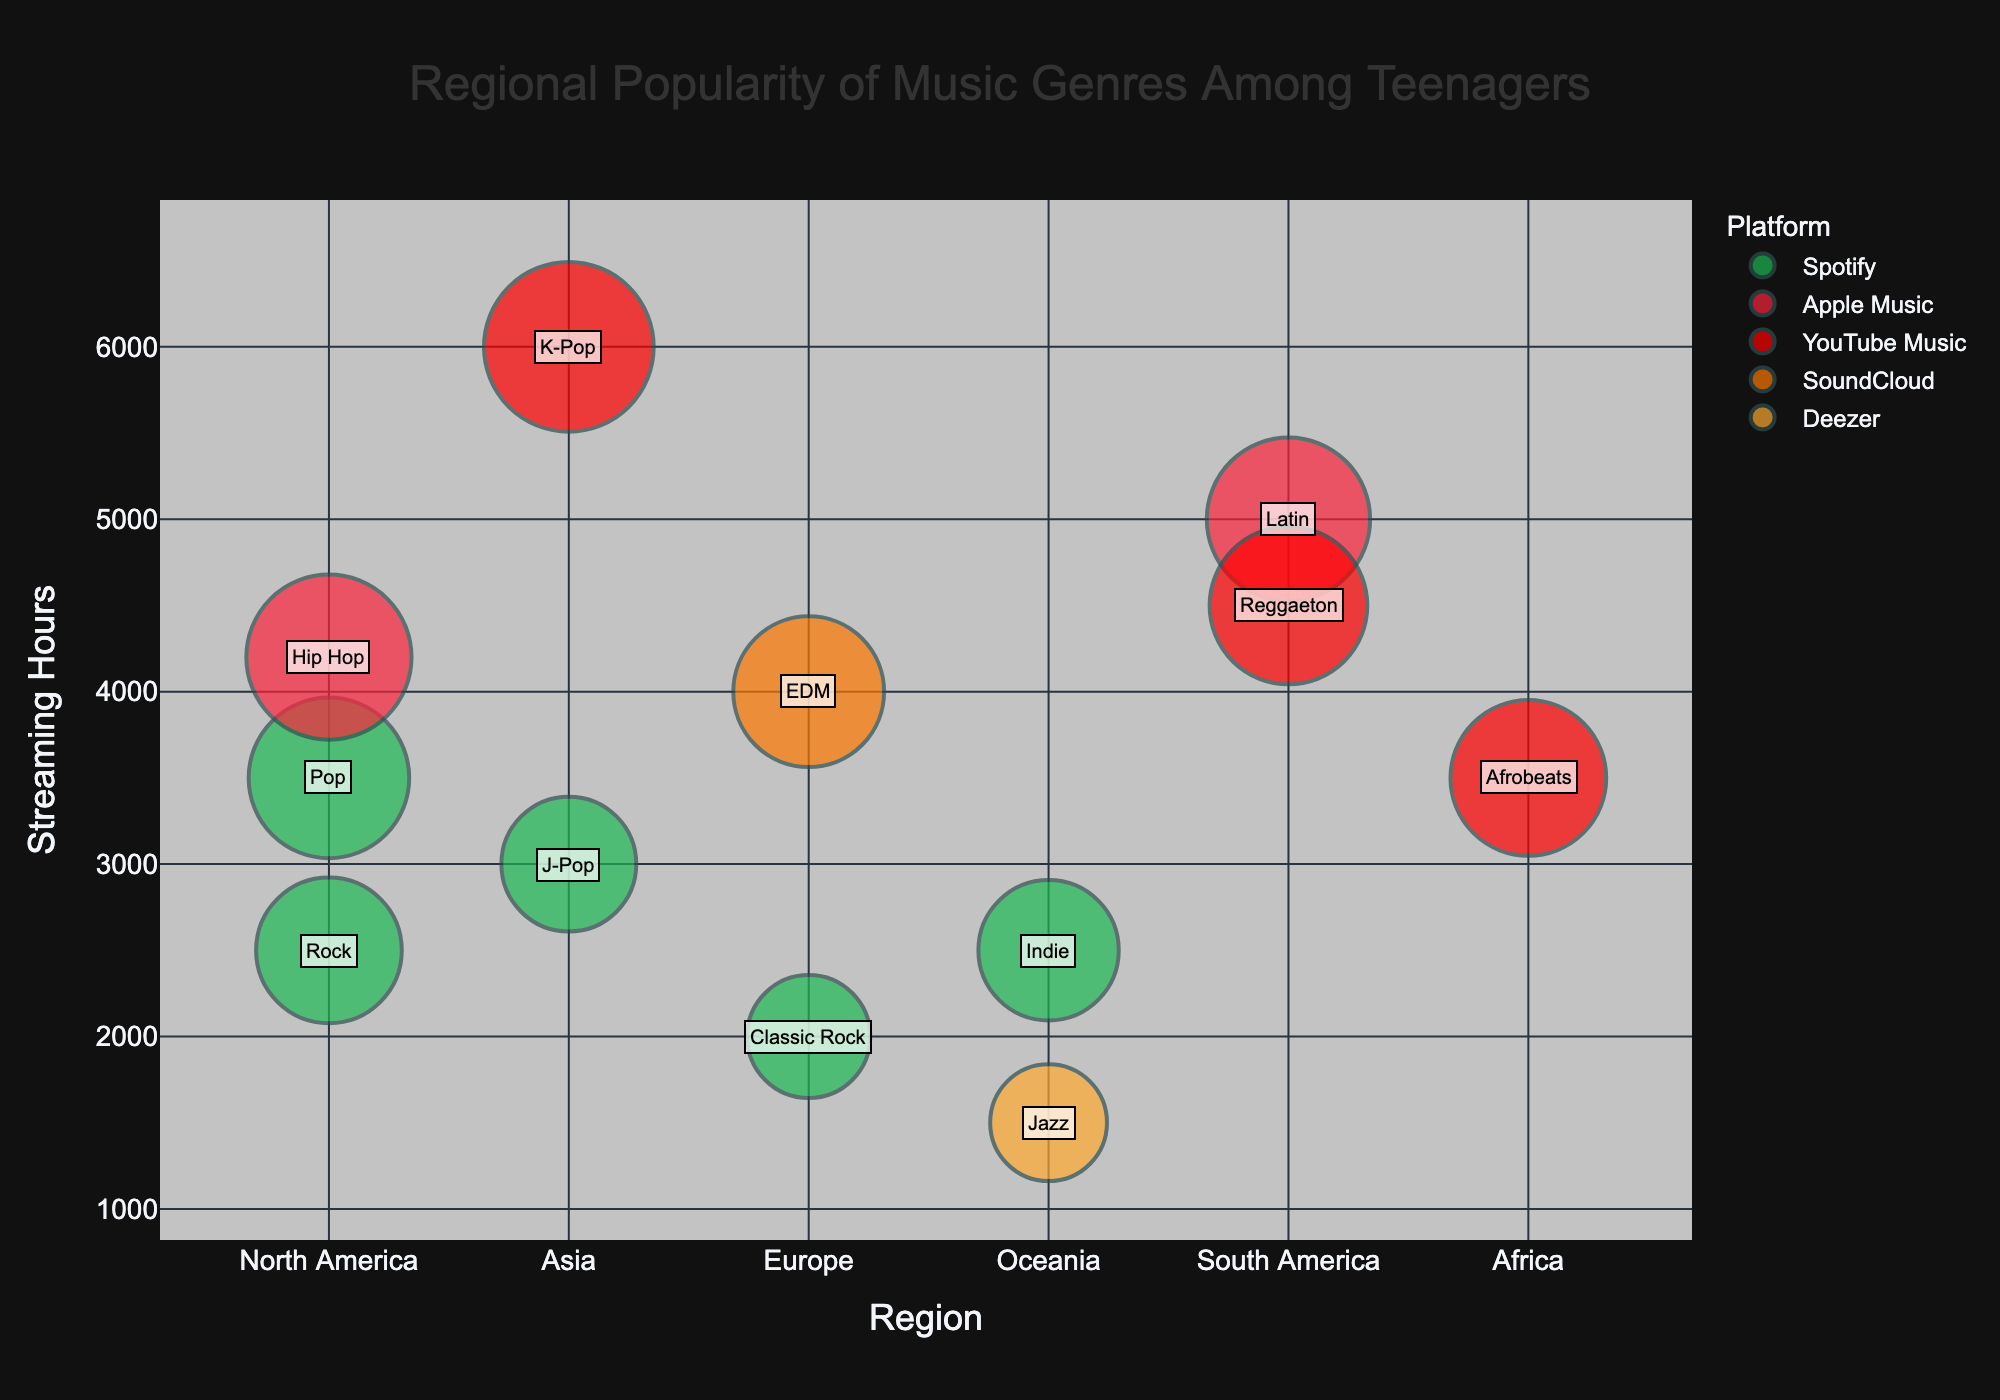What is the title of the chart? The title of the chart is placed at the top center of the figure. It gives a clear indication of what the chart represents.
Answer: Regional Popularity of Music Genres Among Teenagers Which music genre has the highest popularity score in Asia? To determine the genre with the highest popularity score in Asia, look at the bubble size within the Asia region. The largest bubble will correspond to the highest popularity score.
Answer: K-Pop What are the two most popular music platforms in South America, based on the bubble sizes? Identify the two largest bubbles in the South America region and check their colors against the legend to determine the platforms.
Answer: Apple Music and YouTube Music Which region has the highest streaming hours for EDM? Locate the EDM genre on the y-axis and identify the highest value for streaming hours within the different regions.
Answer: Europe What is the most preferred music streaming platform in North America based on bubble sizes? Compare the sizes of the bubbles in North America and check the platform associated with the largest bubble sizes.
Answer: Apple Music How many different music streaming platforms are represented in the chart? Count the unique colors in the chart that correspond to the different platforms based on the legend.
Answer: 5 Which music genre in Oceania has the least streaming hours? Compare the y-axis values of the bubbles corresponding to the Oceania region and find the smallest value.
Answer: Jazz What is the total streaming hours for music genres in Europe? Look at the y-axis values for all the bubbles in Europe and sum these values.
Answer: 6000 (EDM: 4000 + Classic Rock: 2000) Which region shows the most diverse platform preferences? Identify the region with the most unique bubble colors, representing different platforms.
Answer: North America What is the average popularity score of music genres in Asia? Add the popularity scores of all genres in Asia and divide by the number of genres present. K-Pop: 95, J-Pop: 60. The average is (95 + 60) / 2.
Answer: 77.5 